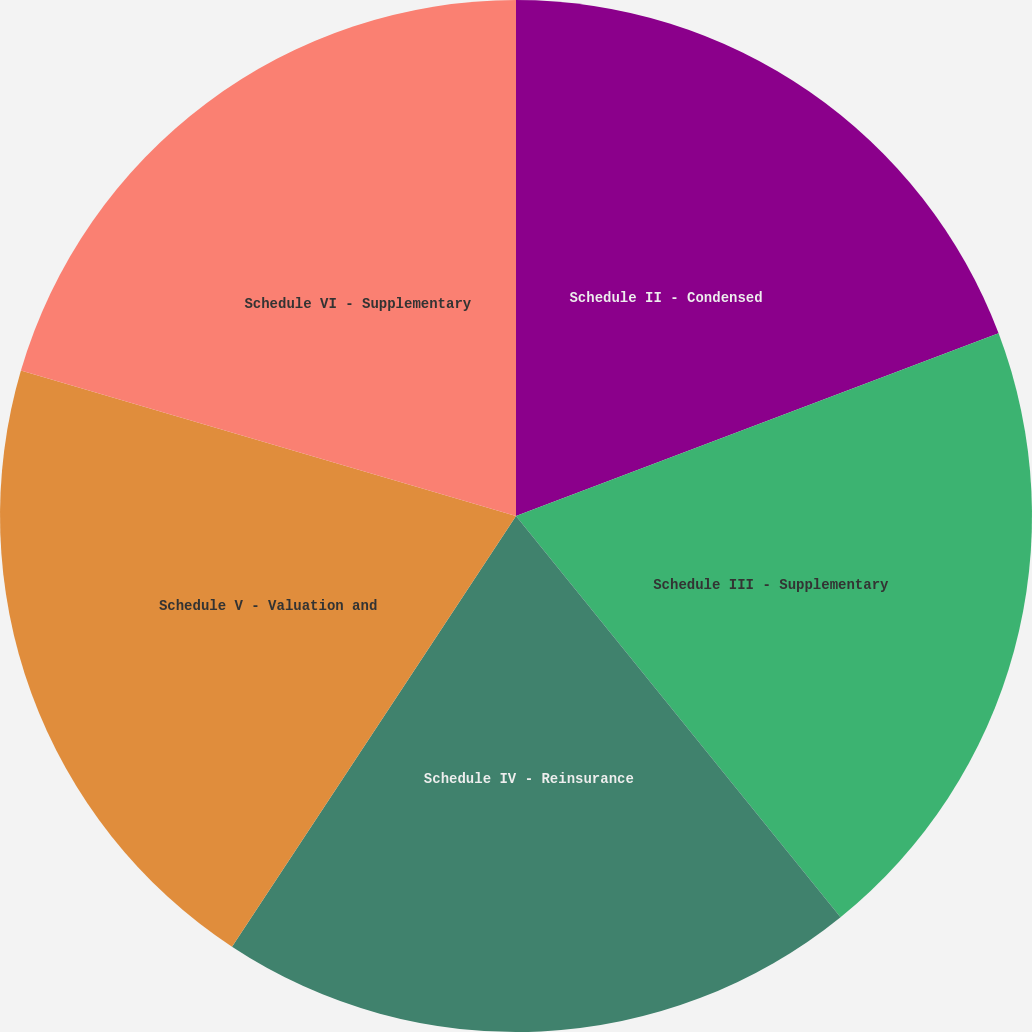Convert chart. <chart><loc_0><loc_0><loc_500><loc_500><pie_chart><fcel>Schedule II - Condensed<fcel>Schedule III - Supplementary<fcel>Schedule IV - Reinsurance<fcel>Schedule V - Valuation and<fcel>Schedule VI - Supplementary<nl><fcel>19.24%<fcel>19.93%<fcel>20.1%<fcel>20.27%<fcel>20.45%<nl></chart> 